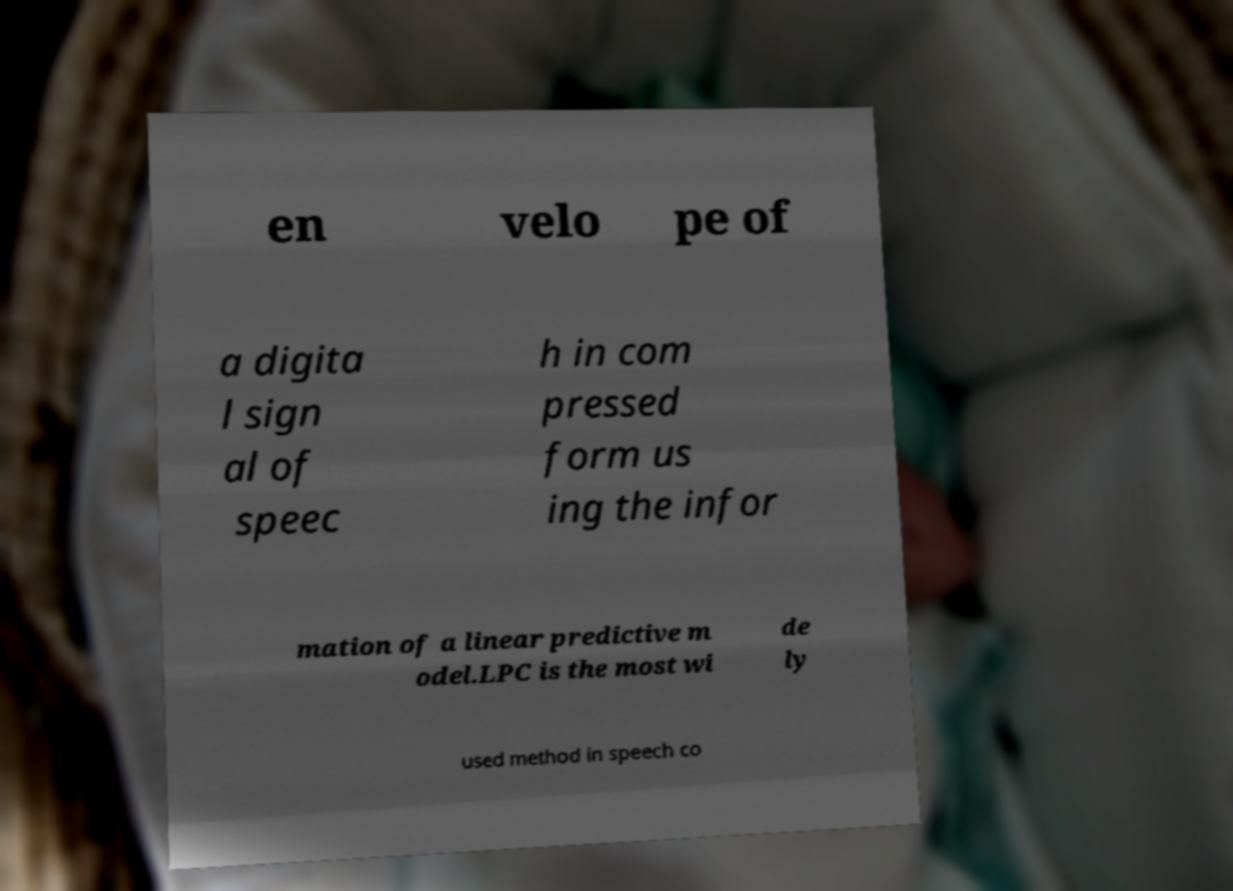There's text embedded in this image that I need extracted. Can you transcribe it verbatim? en velo pe of a digita l sign al of speec h in com pressed form us ing the infor mation of a linear predictive m odel.LPC is the most wi de ly used method in speech co 